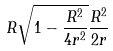Convert formula to latex. <formula><loc_0><loc_0><loc_500><loc_500>R \sqrt { 1 - \frac { R ^ { 2 } } { 4 r ^ { 2 } } } \frac { R ^ { 2 } } { 2 r }</formula> 